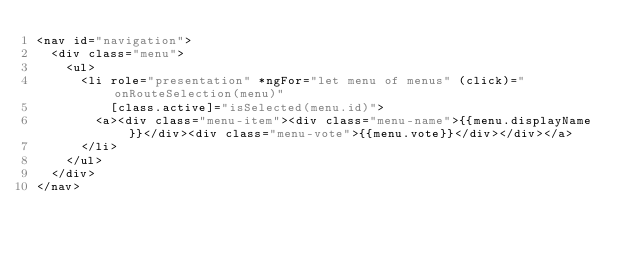Convert code to text. <code><loc_0><loc_0><loc_500><loc_500><_HTML_><nav id="navigation">
  <div class="menu">
    <ul>
      <li role="presentation" *ngFor="let menu of menus" (click)="onRouteSelection(menu)"
          [class.active]="isSelected(menu.id)">
        <a><div class="menu-item"><div class="menu-name">{{menu.displayName}}</div><div class="menu-vote">{{menu.vote}}</div></div></a>
      </li>
    </ul>
  </div>
</nav>
</code> 